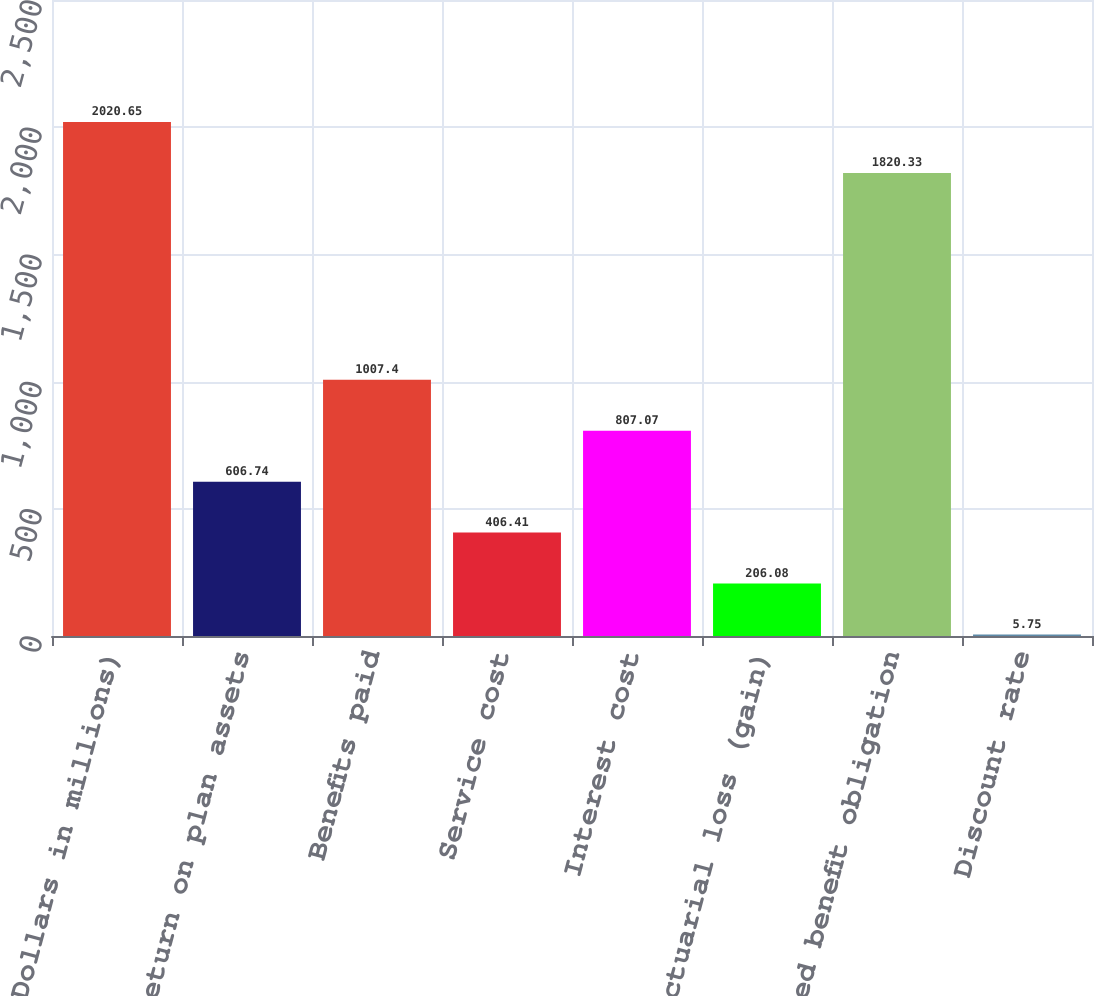Convert chart. <chart><loc_0><loc_0><loc_500><loc_500><bar_chart><fcel>(Dollars in millions)<fcel>Actual return on plan assets<fcel>Benefits paid<fcel>Service cost<fcel>Interest cost<fcel>Actuarial loss (gain)<fcel>Projected benefit obligation<fcel>Discount rate<nl><fcel>2020.65<fcel>606.74<fcel>1007.4<fcel>406.41<fcel>807.07<fcel>206.08<fcel>1820.33<fcel>5.75<nl></chart> 